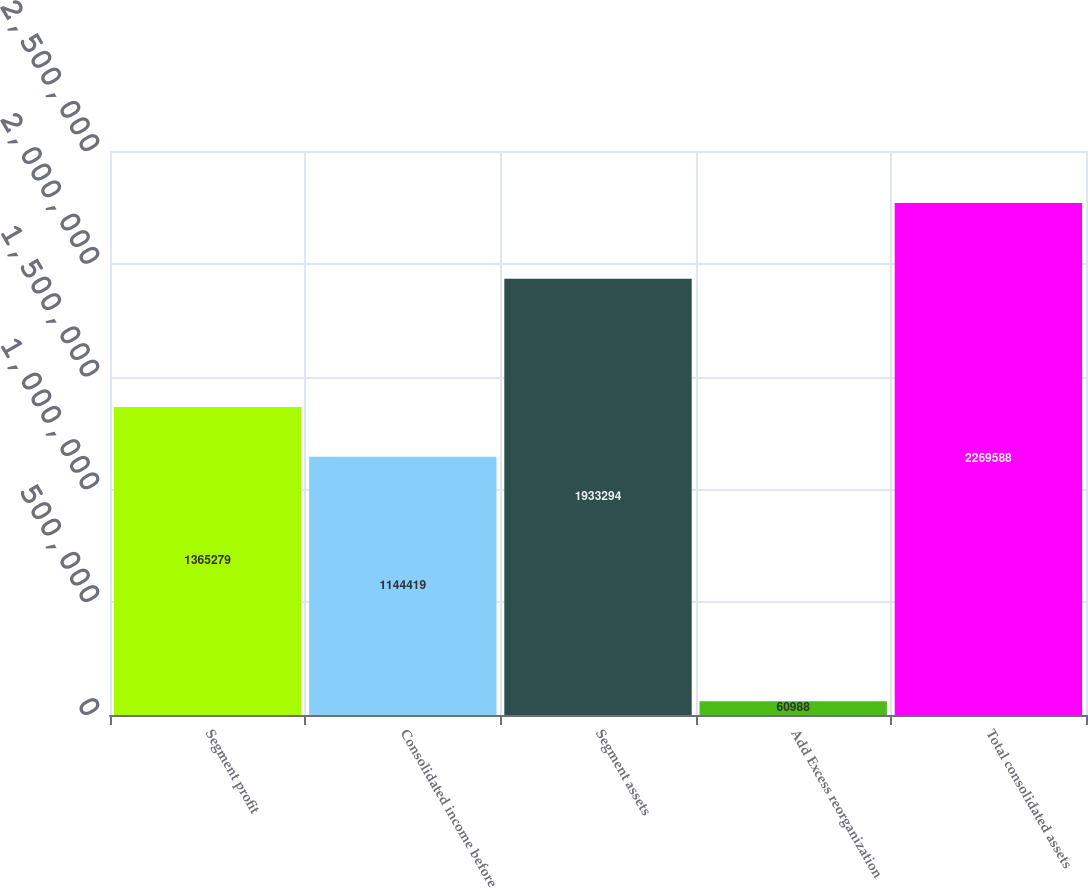<chart> <loc_0><loc_0><loc_500><loc_500><bar_chart><fcel>Segment profit<fcel>Consolidated income before<fcel>Segment assets<fcel>Add Excess reorganization<fcel>Total consolidated assets<nl><fcel>1.36528e+06<fcel>1.14442e+06<fcel>1.93329e+06<fcel>60988<fcel>2.26959e+06<nl></chart> 